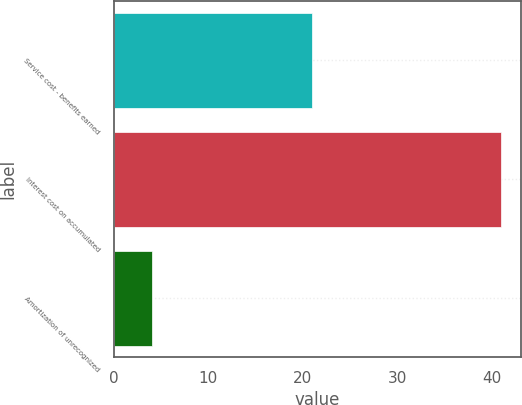Convert chart to OTSL. <chart><loc_0><loc_0><loc_500><loc_500><bar_chart><fcel>Service cost - benefits earned<fcel>Interest cost on accumulated<fcel>Amortization of unrecognized<nl><fcel>21<fcel>41<fcel>4<nl></chart> 